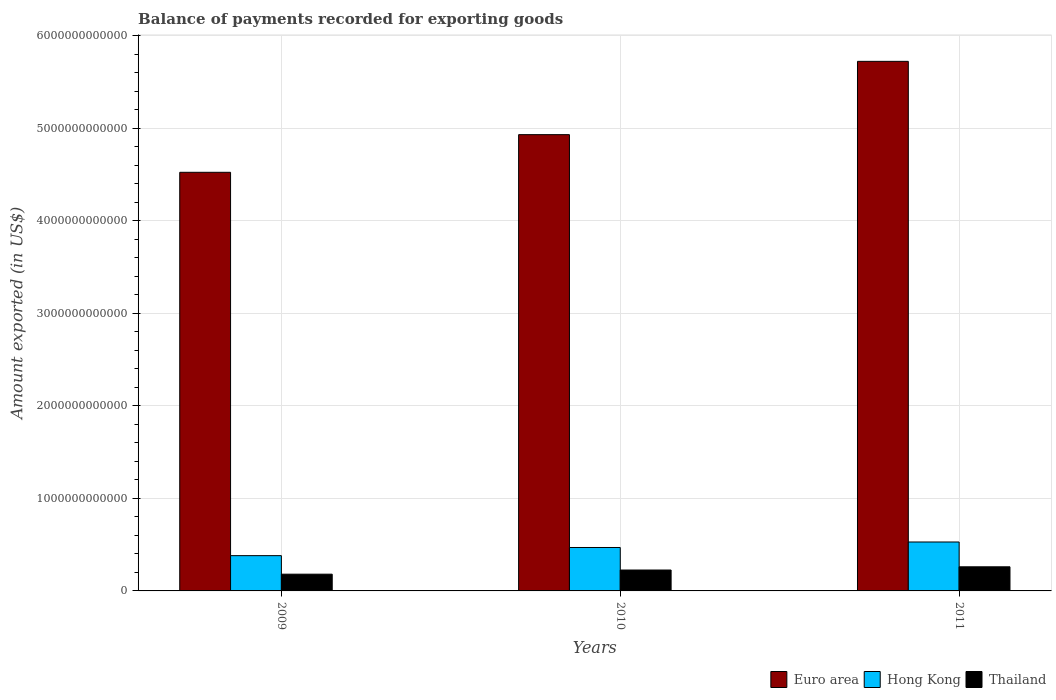Are the number of bars per tick equal to the number of legend labels?
Offer a terse response. Yes. How many bars are there on the 3rd tick from the left?
Ensure brevity in your answer.  3. How many bars are there on the 2nd tick from the right?
Make the answer very short. 3. What is the label of the 3rd group of bars from the left?
Make the answer very short. 2011. What is the amount exported in Thailand in 2009?
Your answer should be compact. 1.81e+11. Across all years, what is the maximum amount exported in Hong Kong?
Keep it short and to the point. 5.29e+11. Across all years, what is the minimum amount exported in Euro area?
Ensure brevity in your answer.  4.53e+12. In which year was the amount exported in Euro area maximum?
Give a very brief answer. 2011. What is the total amount exported in Hong Kong in the graph?
Provide a short and direct response. 1.38e+12. What is the difference between the amount exported in Hong Kong in 2009 and that in 2011?
Give a very brief answer. -1.48e+11. What is the difference between the amount exported in Euro area in 2010 and the amount exported in Hong Kong in 2009?
Your response must be concise. 4.55e+12. What is the average amount exported in Euro area per year?
Your response must be concise. 5.06e+12. In the year 2009, what is the difference between the amount exported in Euro area and amount exported in Thailand?
Keep it short and to the point. 4.34e+12. What is the ratio of the amount exported in Thailand in 2009 to that in 2010?
Give a very brief answer. 0.8. Is the amount exported in Thailand in 2009 less than that in 2010?
Ensure brevity in your answer.  Yes. Is the difference between the amount exported in Euro area in 2009 and 2010 greater than the difference between the amount exported in Thailand in 2009 and 2010?
Give a very brief answer. No. What is the difference between the highest and the second highest amount exported in Hong Kong?
Keep it short and to the point. 5.95e+1. What is the difference between the highest and the lowest amount exported in Thailand?
Your response must be concise. 7.97e+1. In how many years, is the amount exported in Euro area greater than the average amount exported in Euro area taken over all years?
Offer a very short reply. 1. Is the sum of the amount exported in Thailand in 2010 and 2011 greater than the maximum amount exported in Euro area across all years?
Keep it short and to the point. No. What does the 2nd bar from the right in 2009 represents?
Ensure brevity in your answer.  Hong Kong. Are all the bars in the graph horizontal?
Give a very brief answer. No. What is the difference between two consecutive major ticks on the Y-axis?
Make the answer very short. 1.00e+12. Does the graph contain any zero values?
Your response must be concise. No. Does the graph contain grids?
Provide a short and direct response. Yes. Where does the legend appear in the graph?
Offer a very short reply. Bottom right. How many legend labels are there?
Your answer should be very brief. 3. What is the title of the graph?
Provide a short and direct response. Balance of payments recorded for exporting goods. What is the label or title of the Y-axis?
Make the answer very short. Amount exported (in US$). What is the Amount exported (in US$) in Euro area in 2009?
Ensure brevity in your answer.  4.53e+12. What is the Amount exported (in US$) in Hong Kong in 2009?
Make the answer very short. 3.81e+11. What is the Amount exported (in US$) in Thailand in 2009?
Make the answer very short. 1.81e+11. What is the Amount exported (in US$) in Euro area in 2010?
Your response must be concise. 4.93e+12. What is the Amount exported (in US$) in Hong Kong in 2010?
Offer a very short reply. 4.69e+11. What is the Amount exported (in US$) in Thailand in 2010?
Give a very brief answer. 2.26e+11. What is the Amount exported (in US$) of Euro area in 2011?
Keep it short and to the point. 5.72e+12. What is the Amount exported (in US$) in Hong Kong in 2011?
Provide a short and direct response. 5.29e+11. What is the Amount exported (in US$) of Thailand in 2011?
Your answer should be compact. 2.61e+11. Across all years, what is the maximum Amount exported (in US$) of Euro area?
Your answer should be compact. 5.72e+12. Across all years, what is the maximum Amount exported (in US$) in Hong Kong?
Provide a short and direct response. 5.29e+11. Across all years, what is the maximum Amount exported (in US$) in Thailand?
Provide a succinct answer. 2.61e+11. Across all years, what is the minimum Amount exported (in US$) in Euro area?
Your response must be concise. 4.53e+12. Across all years, what is the minimum Amount exported (in US$) of Hong Kong?
Offer a terse response. 3.81e+11. Across all years, what is the minimum Amount exported (in US$) of Thailand?
Give a very brief answer. 1.81e+11. What is the total Amount exported (in US$) of Euro area in the graph?
Provide a short and direct response. 1.52e+13. What is the total Amount exported (in US$) in Hong Kong in the graph?
Your answer should be compact. 1.38e+12. What is the total Amount exported (in US$) of Thailand in the graph?
Your response must be concise. 6.68e+11. What is the difference between the Amount exported (in US$) of Euro area in 2009 and that in 2010?
Offer a terse response. -4.07e+11. What is the difference between the Amount exported (in US$) of Hong Kong in 2009 and that in 2010?
Offer a terse response. -8.81e+1. What is the difference between the Amount exported (in US$) in Thailand in 2009 and that in 2010?
Provide a succinct answer. -4.50e+1. What is the difference between the Amount exported (in US$) in Euro area in 2009 and that in 2011?
Give a very brief answer. -1.20e+12. What is the difference between the Amount exported (in US$) of Hong Kong in 2009 and that in 2011?
Make the answer very short. -1.48e+11. What is the difference between the Amount exported (in US$) in Thailand in 2009 and that in 2011?
Provide a succinct answer. -7.97e+1. What is the difference between the Amount exported (in US$) of Euro area in 2010 and that in 2011?
Provide a succinct answer. -7.92e+11. What is the difference between the Amount exported (in US$) of Hong Kong in 2010 and that in 2011?
Offer a very short reply. -5.95e+1. What is the difference between the Amount exported (in US$) of Thailand in 2010 and that in 2011?
Your answer should be compact. -3.48e+1. What is the difference between the Amount exported (in US$) of Euro area in 2009 and the Amount exported (in US$) of Hong Kong in 2010?
Ensure brevity in your answer.  4.06e+12. What is the difference between the Amount exported (in US$) in Euro area in 2009 and the Amount exported (in US$) in Thailand in 2010?
Your answer should be very brief. 4.30e+12. What is the difference between the Amount exported (in US$) of Hong Kong in 2009 and the Amount exported (in US$) of Thailand in 2010?
Keep it short and to the point. 1.55e+11. What is the difference between the Amount exported (in US$) in Euro area in 2009 and the Amount exported (in US$) in Hong Kong in 2011?
Provide a succinct answer. 4.00e+12. What is the difference between the Amount exported (in US$) of Euro area in 2009 and the Amount exported (in US$) of Thailand in 2011?
Provide a short and direct response. 4.26e+12. What is the difference between the Amount exported (in US$) of Hong Kong in 2009 and the Amount exported (in US$) of Thailand in 2011?
Keep it short and to the point. 1.21e+11. What is the difference between the Amount exported (in US$) in Euro area in 2010 and the Amount exported (in US$) in Hong Kong in 2011?
Provide a succinct answer. 4.40e+12. What is the difference between the Amount exported (in US$) of Euro area in 2010 and the Amount exported (in US$) of Thailand in 2011?
Your answer should be compact. 4.67e+12. What is the difference between the Amount exported (in US$) in Hong Kong in 2010 and the Amount exported (in US$) in Thailand in 2011?
Provide a succinct answer. 2.09e+11. What is the average Amount exported (in US$) in Euro area per year?
Provide a succinct answer. 5.06e+12. What is the average Amount exported (in US$) in Hong Kong per year?
Your answer should be very brief. 4.60e+11. What is the average Amount exported (in US$) of Thailand per year?
Keep it short and to the point. 2.23e+11. In the year 2009, what is the difference between the Amount exported (in US$) in Euro area and Amount exported (in US$) in Hong Kong?
Provide a short and direct response. 4.14e+12. In the year 2009, what is the difference between the Amount exported (in US$) of Euro area and Amount exported (in US$) of Thailand?
Provide a short and direct response. 4.34e+12. In the year 2009, what is the difference between the Amount exported (in US$) in Hong Kong and Amount exported (in US$) in Thailand?
Your answer should be very brief. 2.00e+11. In the year 2010, what is the difference between the Amount exported (in US$) in Euro area and Amount exported (in US$) in Hong Kong?
Your response must be concise. 4.46e+12. In the year 2010, what is the difference between the Amount exported (in US$) in Euro area and Amount exported (in US$) in Thailand?
Your answer should be compact. 4.71e+12. In the year 2010, what is the difference between the Amount exported (in US$) in Hong Kong and Amount exported (in US$) in Thailand?
Your answer should be very brief. 2.44e+11. In the year 2011, what is the difference between the Amount exported (in US$) in Euro area and Amount exported (in US$) in Hong Kong?
Provide a short and direct response. 5.20e+12. In the year 2011, what is the difference between the Amount exported (in US$) in Euro area and Amount exported (in US$) in Thailand?
Offer a very short reply. 5.46e+12. In the year 2011, what is the difference between the Amount exported (in US$) of Hong Kong and Amount exported (in US$) of Thailand?
Provide a short and direct response. 2.68e+11. What is the ratio of the Amount exported (in US$) of Euro area in 2009 to that in 2010?
Offer a very short reply. 0.92. What is the ratio of the Amount exported (in US$) in Hong Kong in 2009 to that in 2010?
Give a very brief answer. 0.81. What is the ratio of the Amount exported (in US$) in Thailand in 2009 to that in 2010?
Keep it short and to the point. 0.8. What is the ratio of the Amount exported (in US$) of Euro area in 2009 to that in 2011?
Make the answer very short. 0.79. What is the ratio of the Amount exported (in US$) in Hong Kong in 2009 to that in 2011?
Keep it short and to the point. 0.72. What is the ratio of the Amount exported (in US$) in Thailand in 2009 to that in 2011?
Provide a succinct answer. 0.69. What is the ratio of the Amount exported (in US$) in Euro area in 2010 to that in 2011?
Ensure brevity in your answer.  0.86. What is the ratio of the Amount exported (in US$) in Hong Kong in 2010 to that in 2011?
Offer a terse response. 0.89. What is the ratio of the Amount exported (in US$) of Thailand in 2010 to that in 2011?
Provide a short and direct response. 0.87. What is the difference between the highest and the second highest Amount exported (in US$) in Euro area?
Offer a terse response. 7.92e+11. What is the difference between the highest and the second highest Amount exported (in US$) of Hong Kong?
Your answer should be compact. 5.95e+1. What is the difference between the highest and the second highest Amount exported (in US$) in Thailand?
Your answer should be compact. 3.48e+1. What is the difference between the highest and the lowest Amount exported (in US$) of Euro area?
Your response must be concise. 1.20e+12. What is the difference between the highest and the lowest Amount exported (in US$) of Hong Kong?
Offer a terse response. 1.48e+11. What is the difference between the highest and the lowest Amount exported (in US$) of Thailand?
Ensure brevity in your answer.  7.97e+1. 